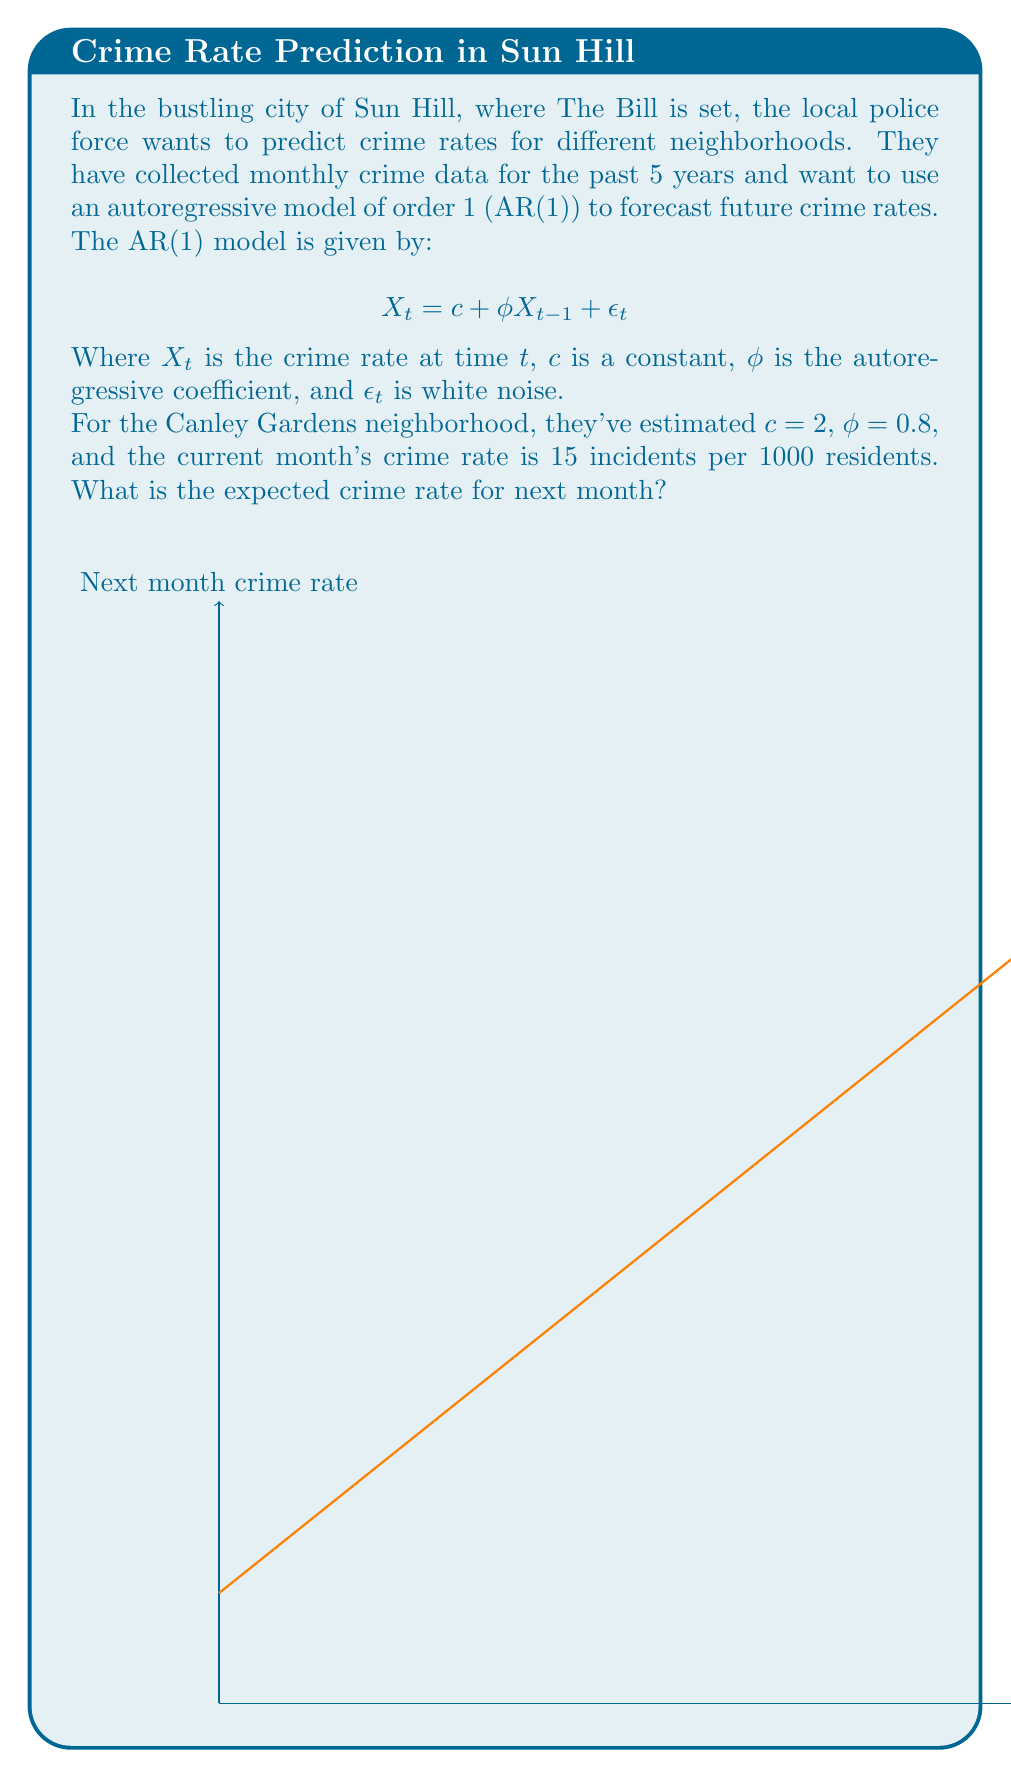Solve this math problem. Let's approach this step-by-step:

1) The AR(1) model is given by:

   $$ X_t = c + \phi X_{t-1} + \epsilon_t $$

2) We're given the following parameters:
   - $c = 2$ (constant)
   - $\phi = 0.8$ (autoregressive coefficient)
   - $X_{t-1} = 15$ (current month's crime rate)

3) To predict the next month's crime rate, we use the expected value of $X_t$. The expected value of the noise term $\epsilon_t$ is zero, so we can ignore it in our calculation.

4) Substituting these values into the equation:

   $$ E[X_t] = c + \phi X_{t-1} $$
   $$ E[X_t] = 2 + 0.8 * 15 $$

5) Let's calculate:
   $$ E[X_t] = 2 + 12 = 14 $$

Therefore, the expected crime rate for next month is 14 incidents per 1000 residents.
Answer: 14 incidents per 1000 residents 